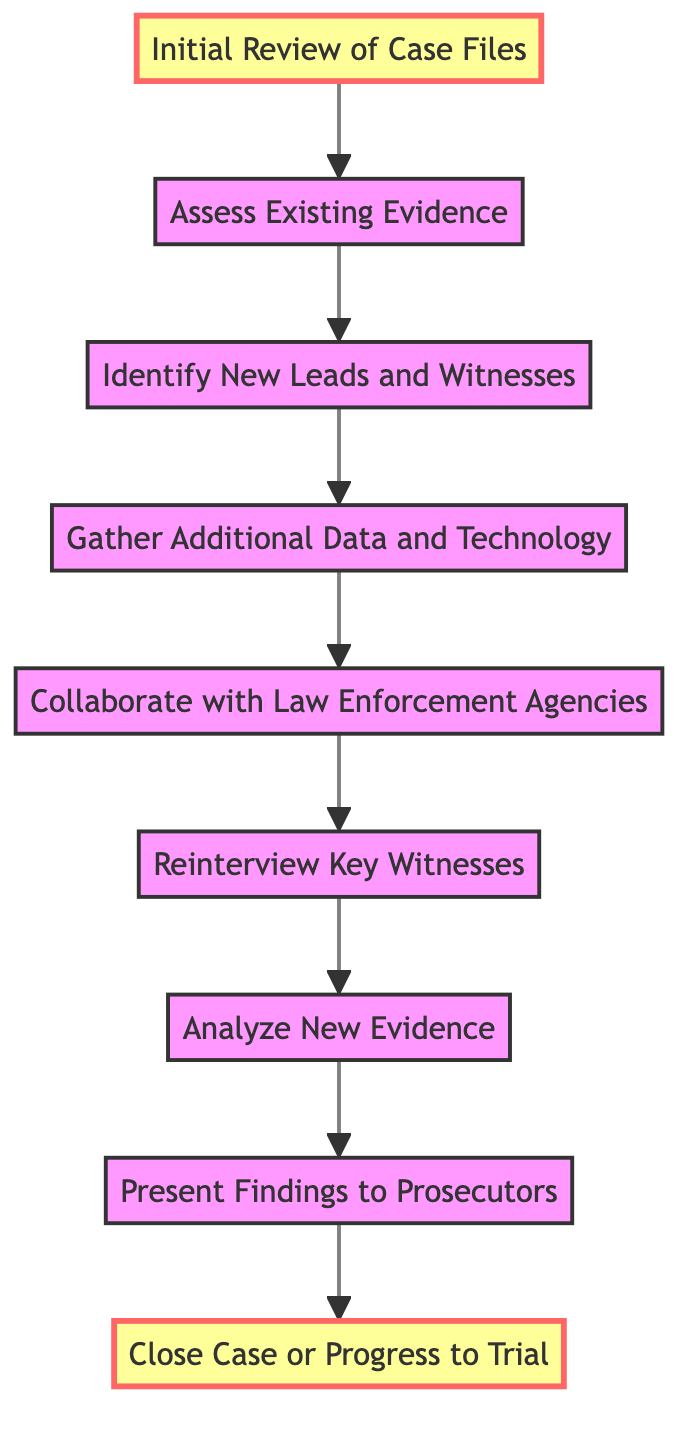What is the first step in the investigative process? The first step in the diagram is identified by the node labeled "Initial Review of Case Files." This node is positioned at the beginning of the flowchart, indicating it is the starting point of the investigative process.
Answer: Initial Review of Case Files How many nodes are in the diagram? By counting each distinct box in the flowchart, we find there are nine nodes: Initial Review, Assess Evidence, Identify Leads, Gather Data, Collaborate, Reinterview, Analyze, Present Findings, and Close Case.
Answer: 9 What is the last step before closing the case? The last step before "Close Case" is represented by the node labeled "Present Findings to Prosecutors." It is the penultimate node that directly connects to the closing action.
Answer: Present Findings to Prosecutors Which node follows "Gather Additional Data and Technology"? According to the diagram, the node that follows "Gather Additional Data and Technology" is "Collaborate with Law Enforcement Agencies," as shown by the arrow connecting the two nodes.
Answer: Collaborate with Law Enforcement Agencies What is the relationship between "Assess Existing Evidence" and "Identify New Leads and Witnesses"? The relationship is a directional one, where "Assess Existing Evidence" leads into "Identify New Leads and Witnesses." This indicates that the action of assessing evidence is a prerequisite for identifying new leads, as per the flow of the diagram.
Answer: Assess Existing Evidence → Identify New Leads and Witnesses How many edges are there in the diagram? To find the number of edges, we need to count the arrows connecting the nodes. There are eight connections (arrows) that link the nine nodes, indicating the flow of the investigative process.
Answer: 8 What step comes after reinterviewing key witnesses? After the "Reinterview Key Witnesses" step, the next step is "Analyze New Evidence," which is the following node in the directed flow of the chart.
Answer: Analyze New Evidence Which node connects to the "Close Case" step? The node that connects to "Close Case or Progress to Trial" is "Present Findings to Prosecutors," indicating that findings must be presented prior to making a decision on closing the case or proceeding to trial.
Answer: Present Findings to Prosecutors 